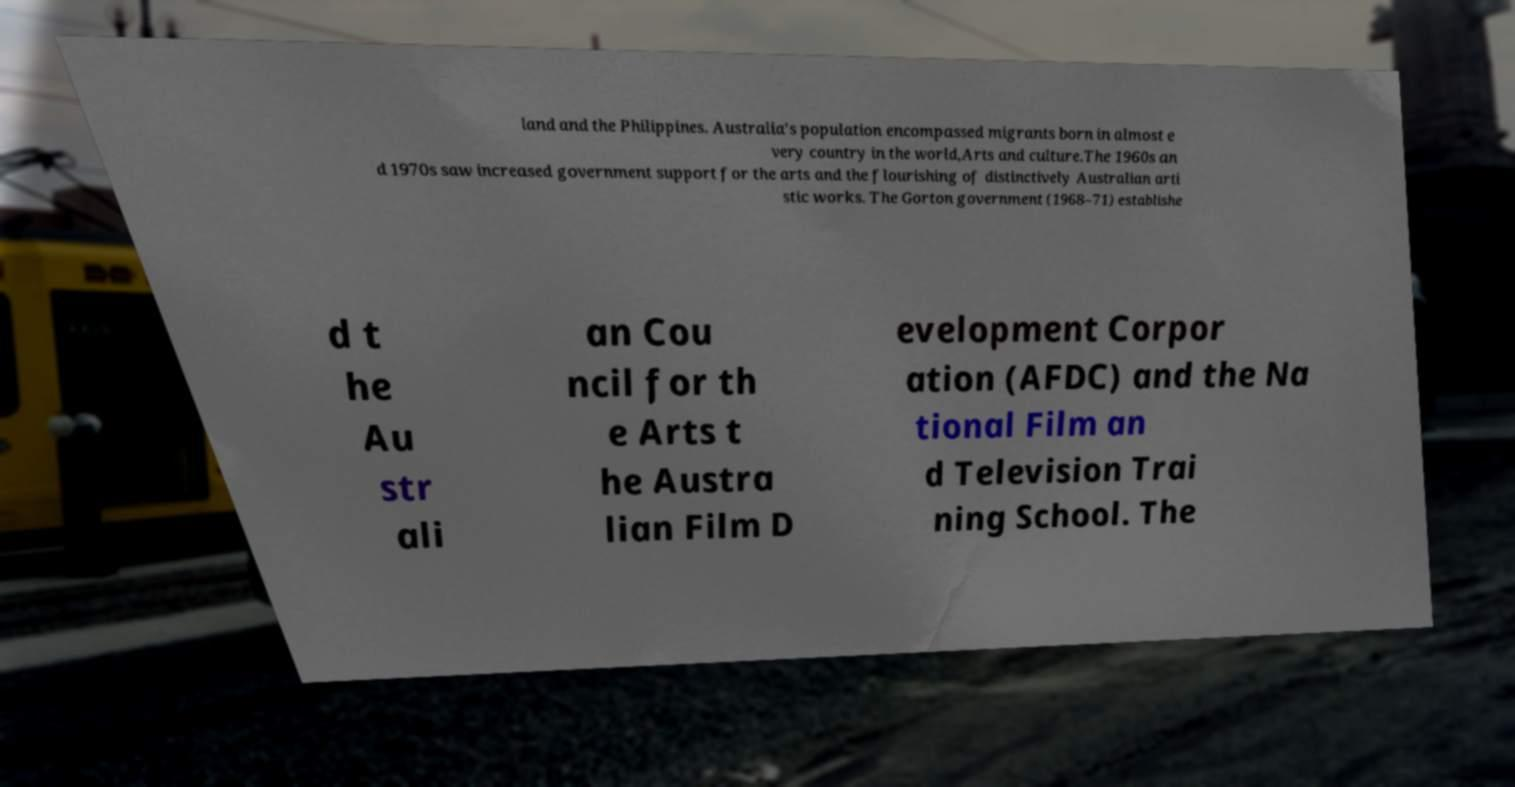Can you accurately transcribe the text from the provided image for me? land and the Philippines. Australia's population encompassed migrants born in almost e very country in the world,Arts and culture.The 1960s an d 1970s saw increased government support for the arts and the flourishing of distinctively Australian arti stic works. The Gorton government (1968–71) establishe d t he Au str ali an Cou ncil for th e Arts t he Austra lian Film D evelopment Corpor ation (AFDC) and the Na tional Film an d Television Trai ning School. The 